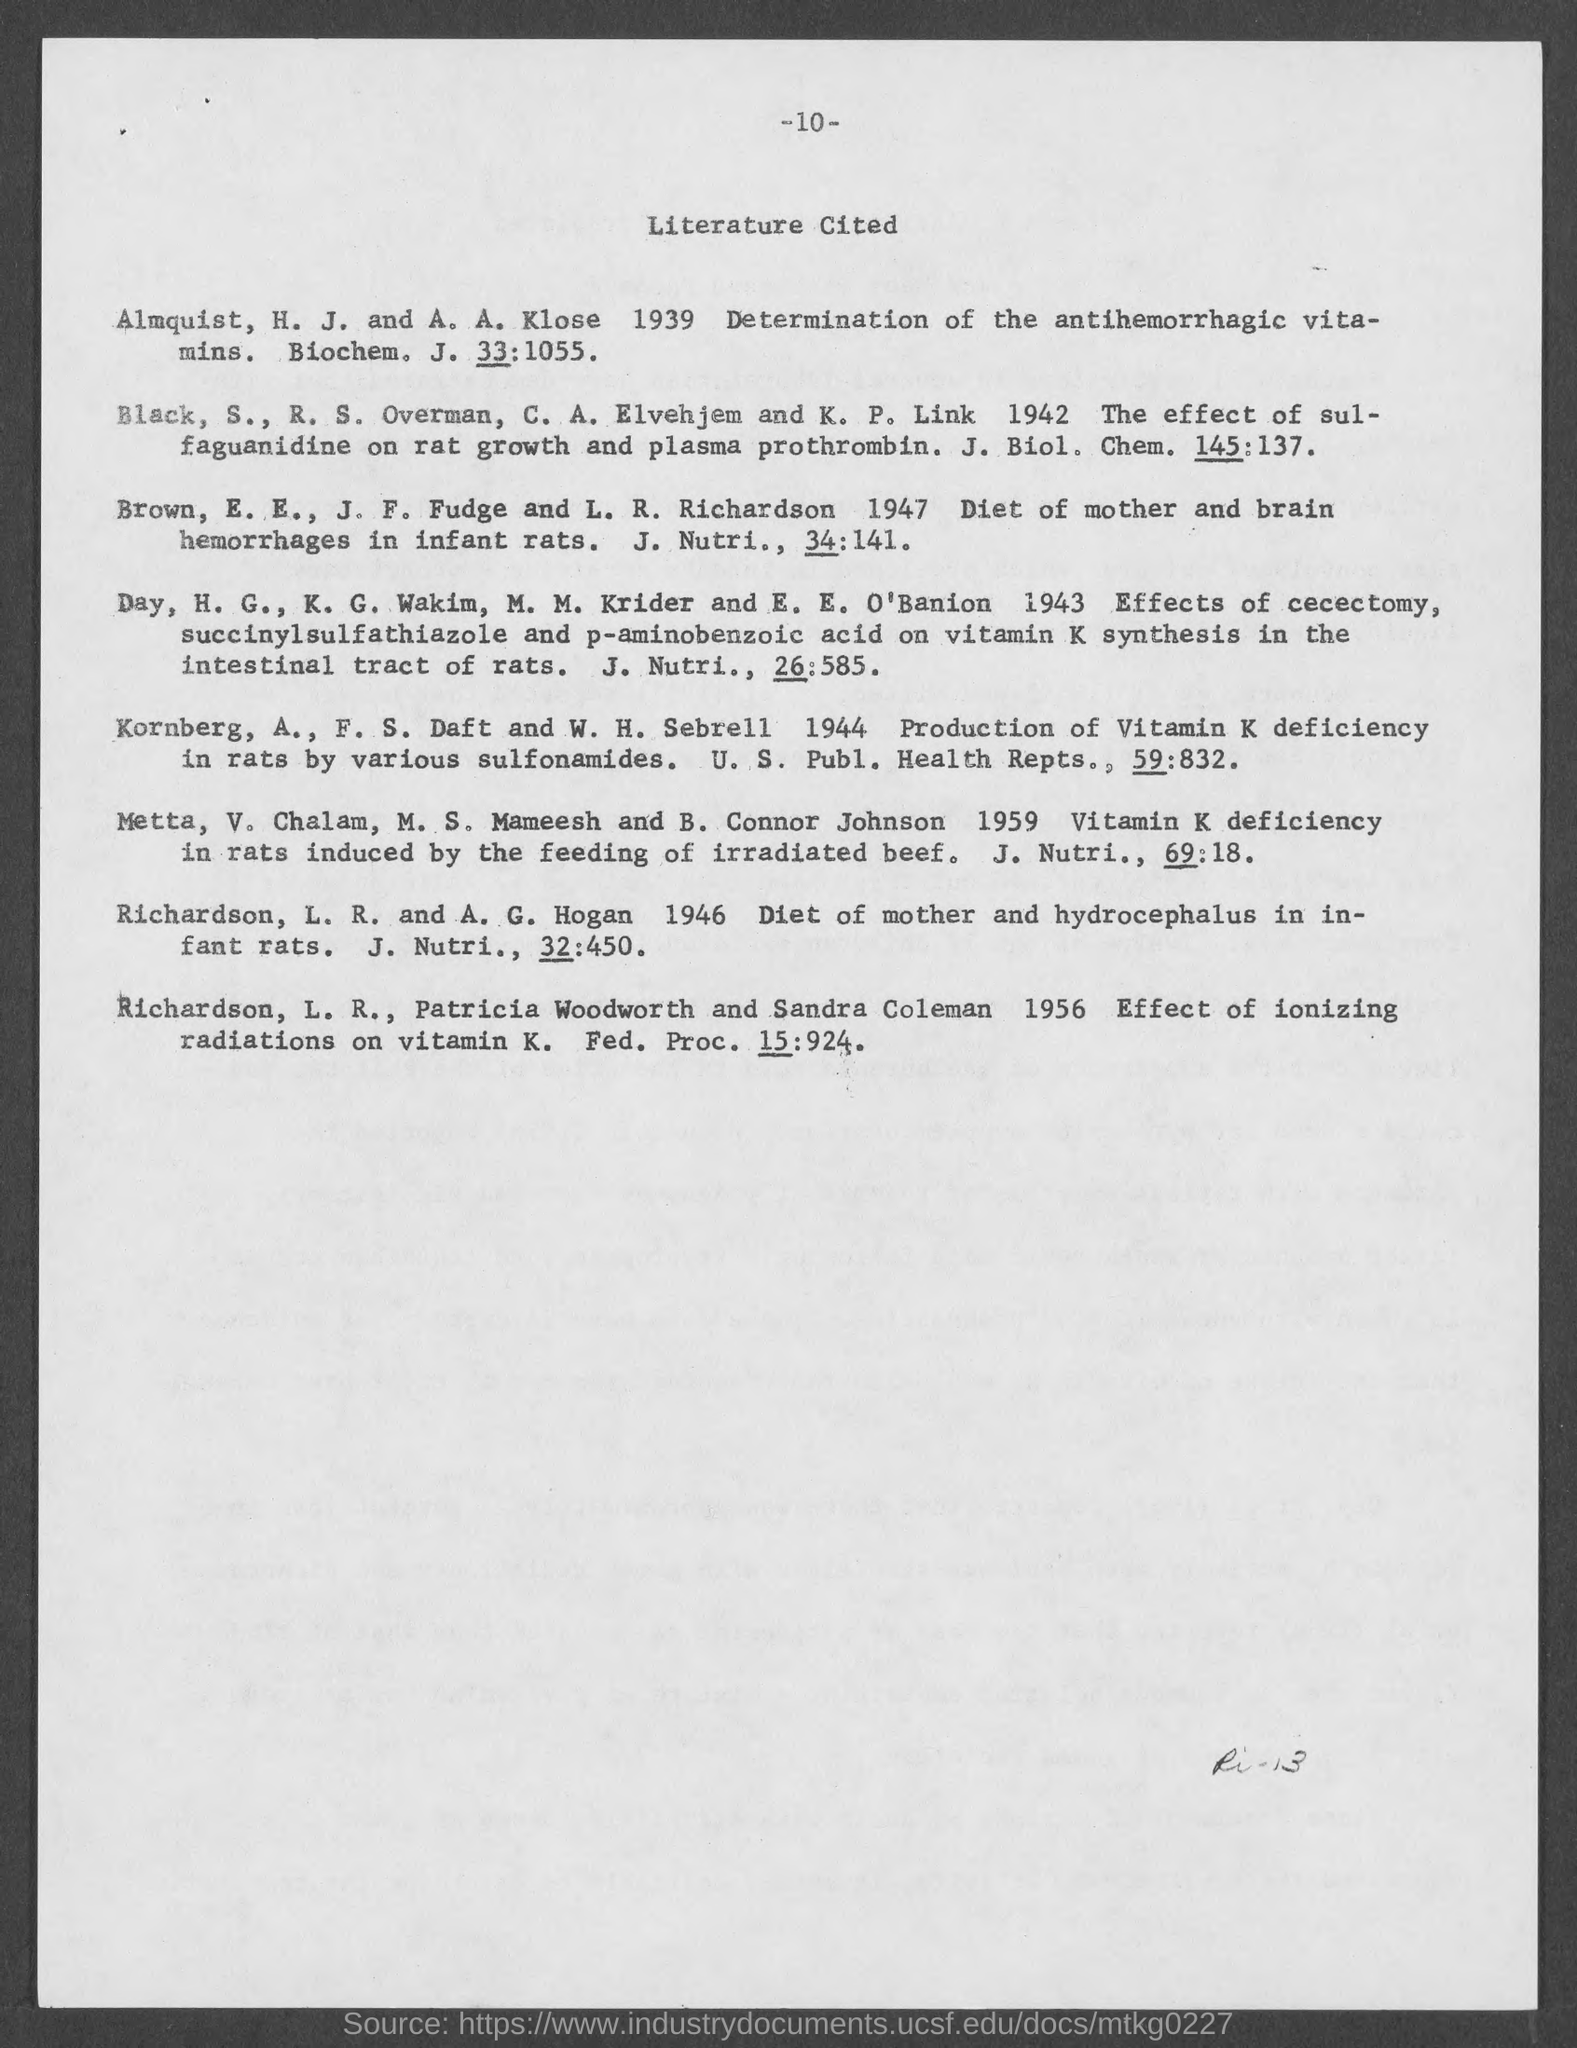Specify some key components in this picture. The title of the document is "Literature Cited. The page number at the top of the page is located -10-. 